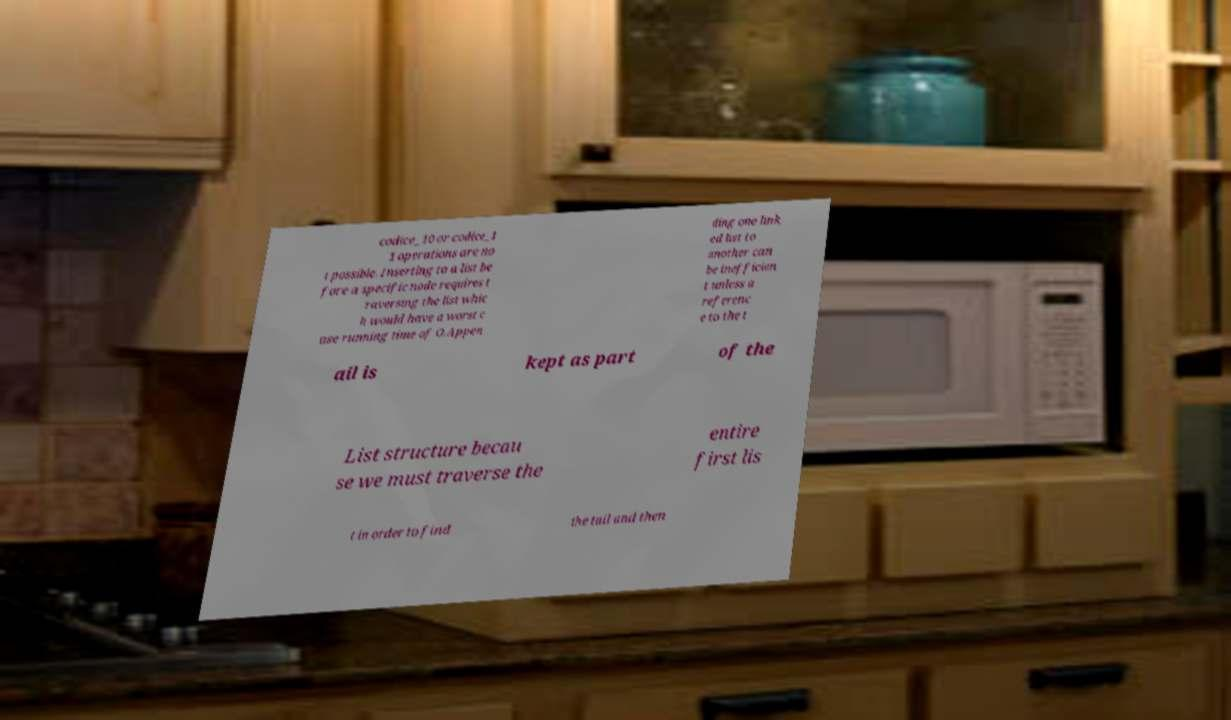Can you read and provide the text displayed in the image?This photo seems to have some interesting text. Can you extract and type it out for me? codice_10 or codice_1 1 operations are no t possible. Inserting to a list be fore a specific node requires t raversing the list whic h would have a worst c ase running time of O.Appen ding one link ed list to another can be inefficien t unless a referenc e to the t ail is kept as part of the List structure becau se we must traverse the entire first lis t in order to find the tail and then 